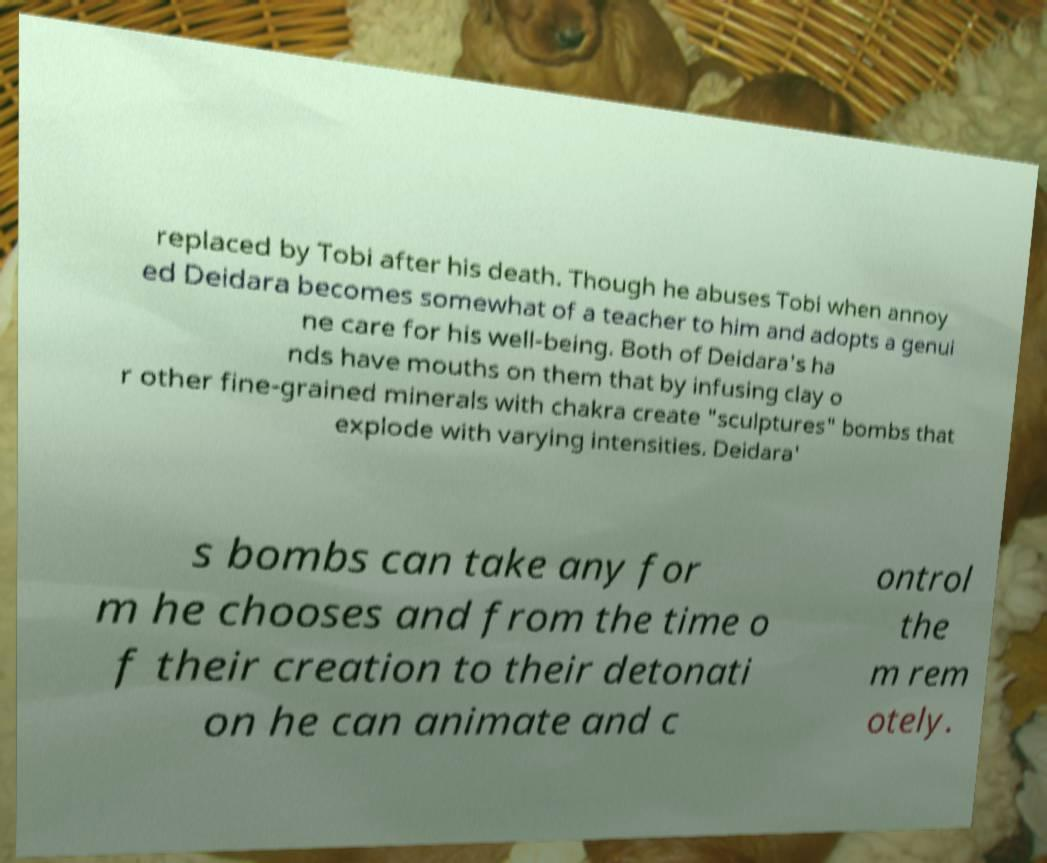Can you accurately transcribe the text from the provided image for me? replaced by Tobi after his death. Though he abuses Tobi when annoy ed Deidara becomes somewhat of a teacher to him and adopts a genui ne care for his well-being. Both of Deidara's ha nds have mouths on them that by infusing clay o r other fine-grained minerals with chakra create "sculptures" bombs that explode with varying intensities. Deidara' s bombs can take any for m he chooses and from the time o f their creation to their detonati on he can animate and c ontrol the m rem otely. 